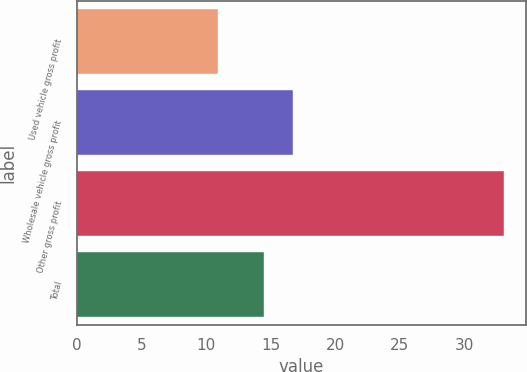Convert chart. <chart><loc_0><loc_0><loc_500><loc_500><bar_chart><fcel>Used vehicle gross profit<fcel>Wholesale vehicle gross profit<fcel>Other gross profit<fcel>Total<nl><fcel>10.9<fcel>16.72<fcel>33.1<fcel>14.5<nl></chart> 